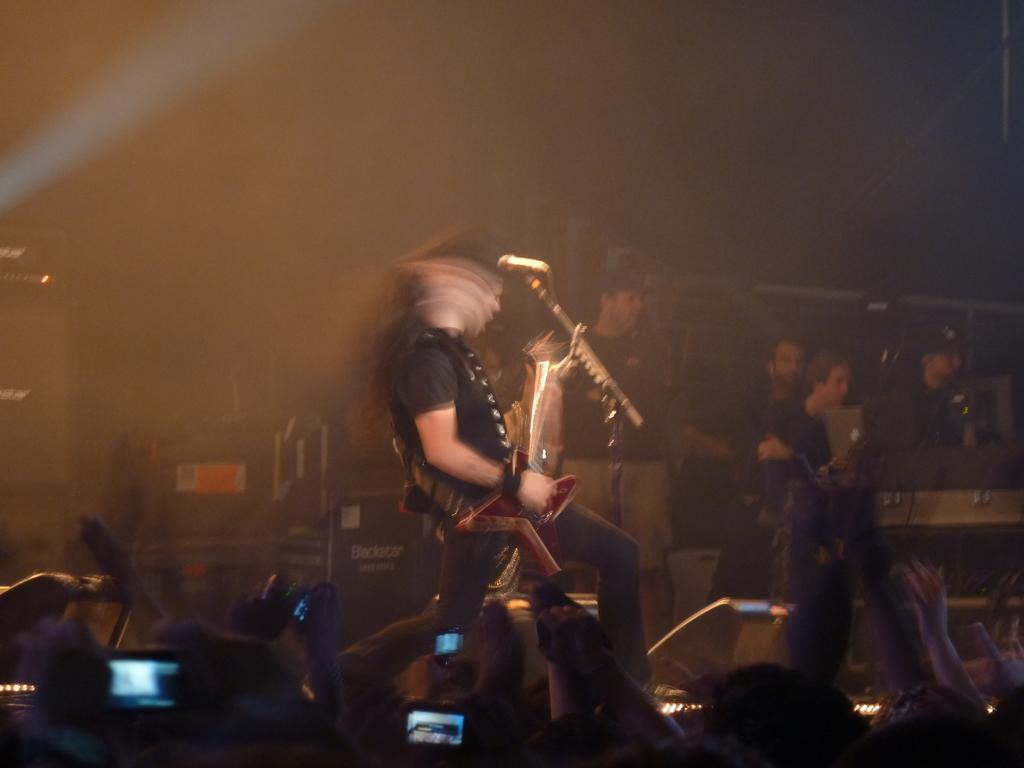What is the person in the image doing? There is a person playing a guitar in the image. What are the other people in the image doing? Some people are sitting, and some are standing in the image. What objects are held by some people in the image? Some people are holding mobile phones in the image. What type of fork can be seen in the image? There is no fork present in the image. What is the opinion of the person playing the guitar about the scissors in the image? There are no scissors or opinions about them in the image, as it only shows people and their actions. 